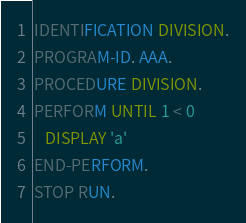Convert code to text. <code><loc_0><loc_0><loc_500><loc_500><_COBOL_>IDENTIFICATION DIVISION.
PROGRAM-ID. AAA.
PROCEDURE DIVISION.
PERFORM UNTIL 1 < 0
   DISPLAY 'a'
END-PERFORM.
STOP RUN.
</code> 